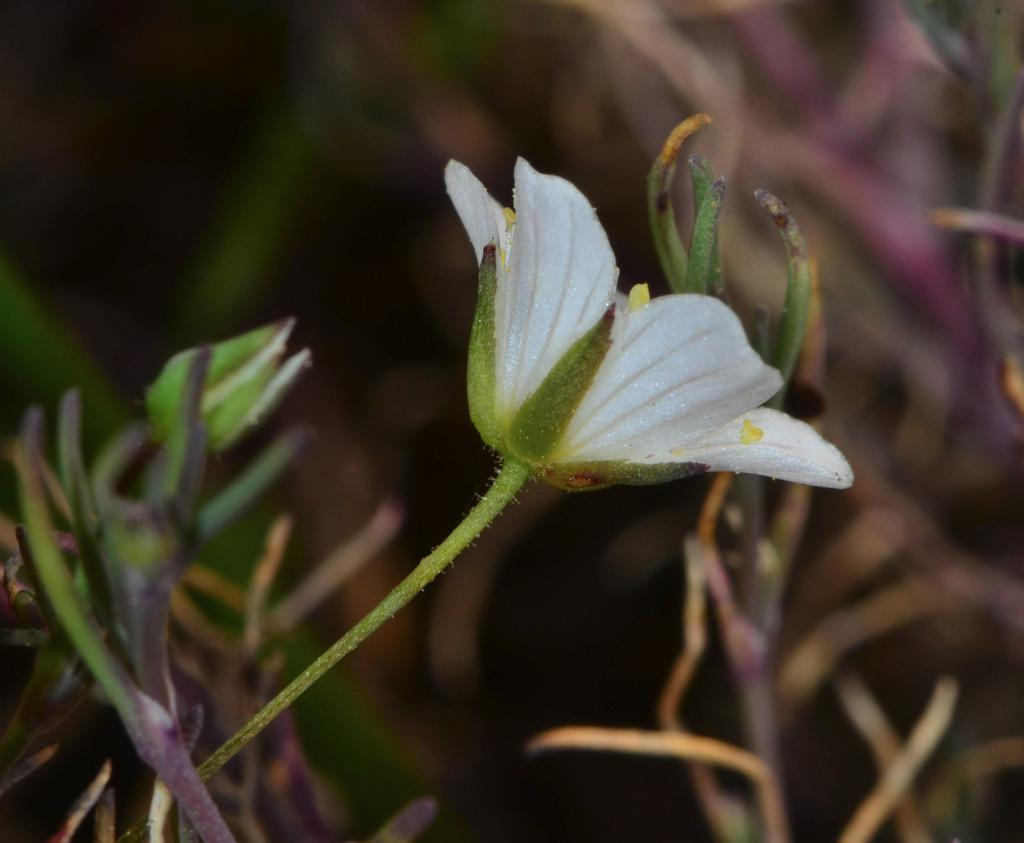What type of plant can be seen in the image? There is a flower and a flower bud in the image, which are both types of plants. Can you describe the stage of growth for the flower in the image? The flower is in full bloom, while the flower bud is still in the process of growing. What other plants are visible in the image? There are plants in the image, but their specific types are not mentioned. How would you describe the background of the image? The background of the image is blurry. What advice does the farmer give to the visitor about the flower's care in the image? There is no farmer or visitor present in the image, so it is not possible to answer this question. 